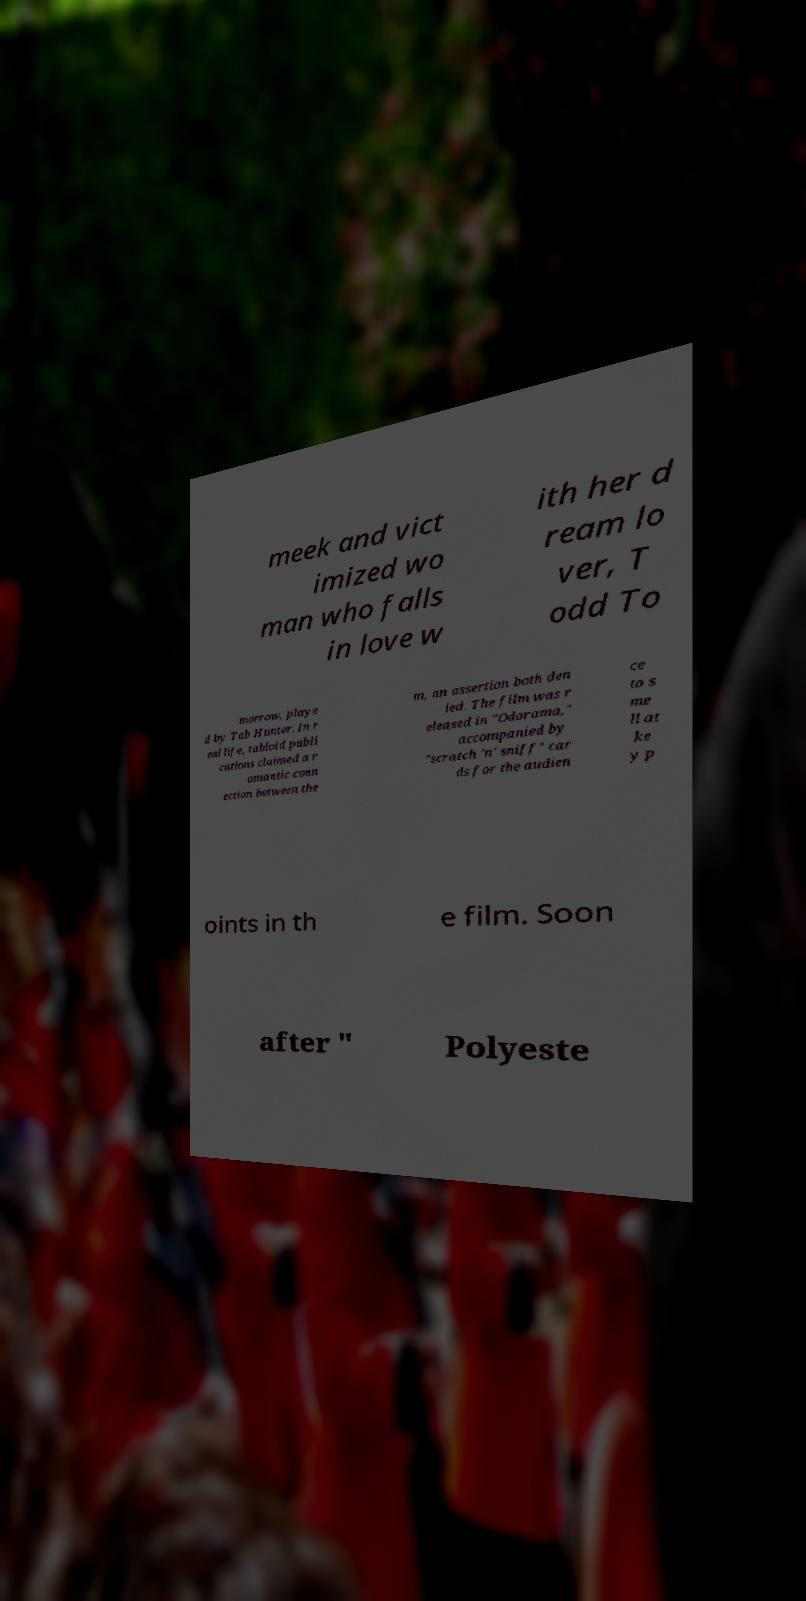Can you accurately transcribe the text from the provided image for me? meek and vict imized wo man who falls in love w ith her d ream lo ver, T odd To morrow, playe d by Tab Hunter. In r eal life, tabloid publi cations claimed a r omantic conn ection between the m, an assertion both den ied. The film was r eleased in "Odorama," accompanied by "scratch 'n' sniff" car ds for the audien ce to s me ll at ke y p oints in th e film. Soon after " Polyeste 